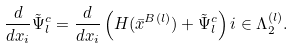<formula> <loc_0><loc_0><loc_500><loc_500>\frac { d } { d x _ { i } } \tilde { \Psi } _ { l } ^ { c } = \frac { d } { d x _ { i } } \left ( H ( \bar { x } ^ { B ( l ) } ) + \tilde { \Psi } _ { l } ^ { c } \right ) i \in \Lambda _ { 2 } ^ { ( l ) } .</formula> 